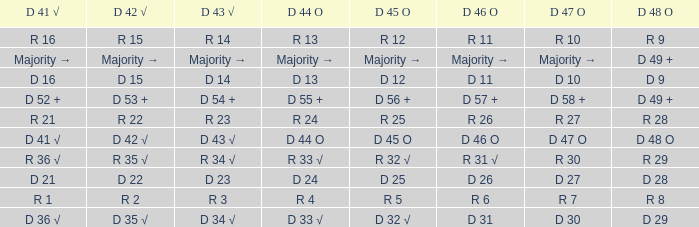Name the D 45 O with D 44 O majority → Majority →. 